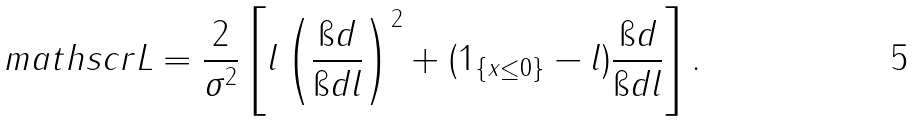Convert formula to latex. <formula><loc_0><loc_0><loc_500><loc_500>\ m a t h s c r { L } = \frac { 2 } { \sigma ^ { 2 } } \left [ l \left ( \frac { \i d } { \i d l } \right ) ^ { 2 } + ( 1 _ { \{ x \leq 0 \} } - l ) \frac { \i d } { \i d l } \right ] .</formula> 